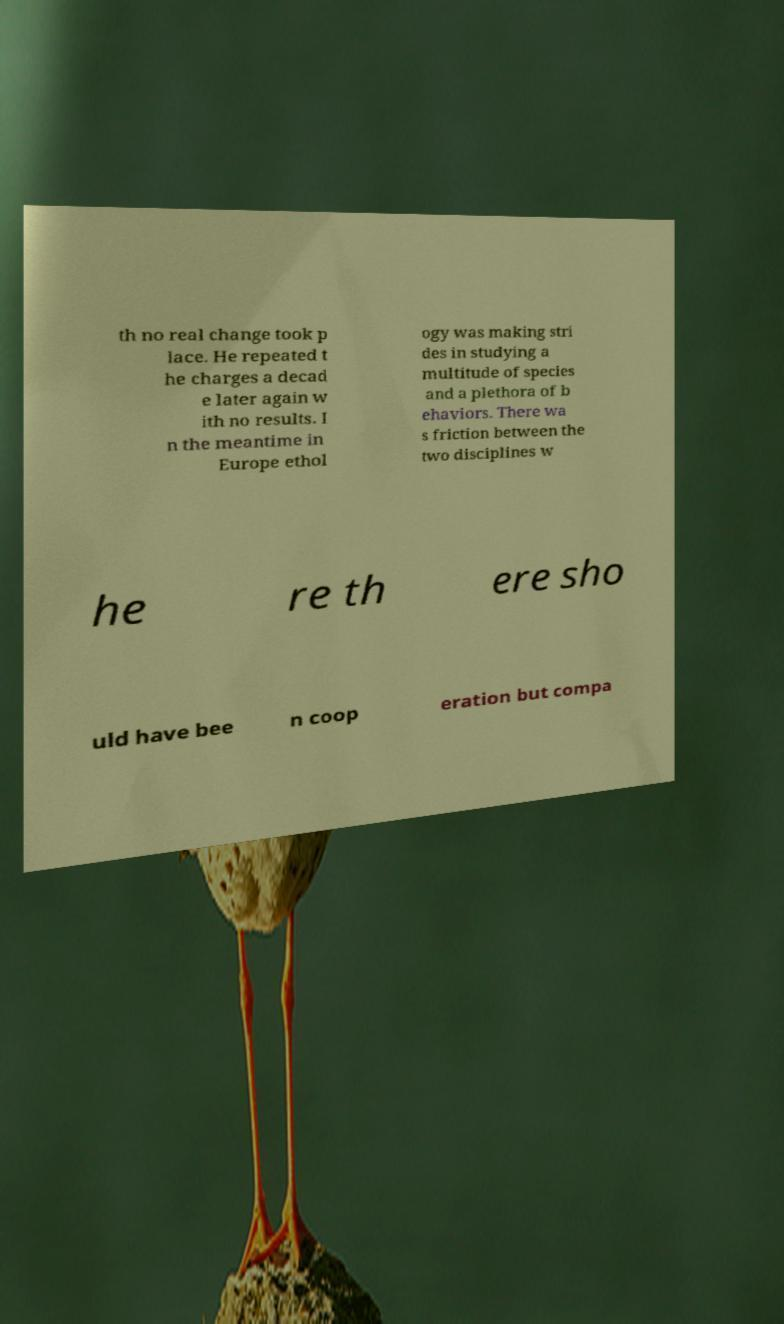Can you read and provide the text displayed in the image?This photo seems to have some interesting text. Can you extract and type it out for me? th no real change took p lace. He repeated t he charges a decad e later again w ith no results. I n the meantime in Europe ethol ogy was making stri des in studying a multitude of species and a plethora of b ehaviors. There wa s friction between the two disciplines w he re th ere sho uld have bee n coop eration but compa 